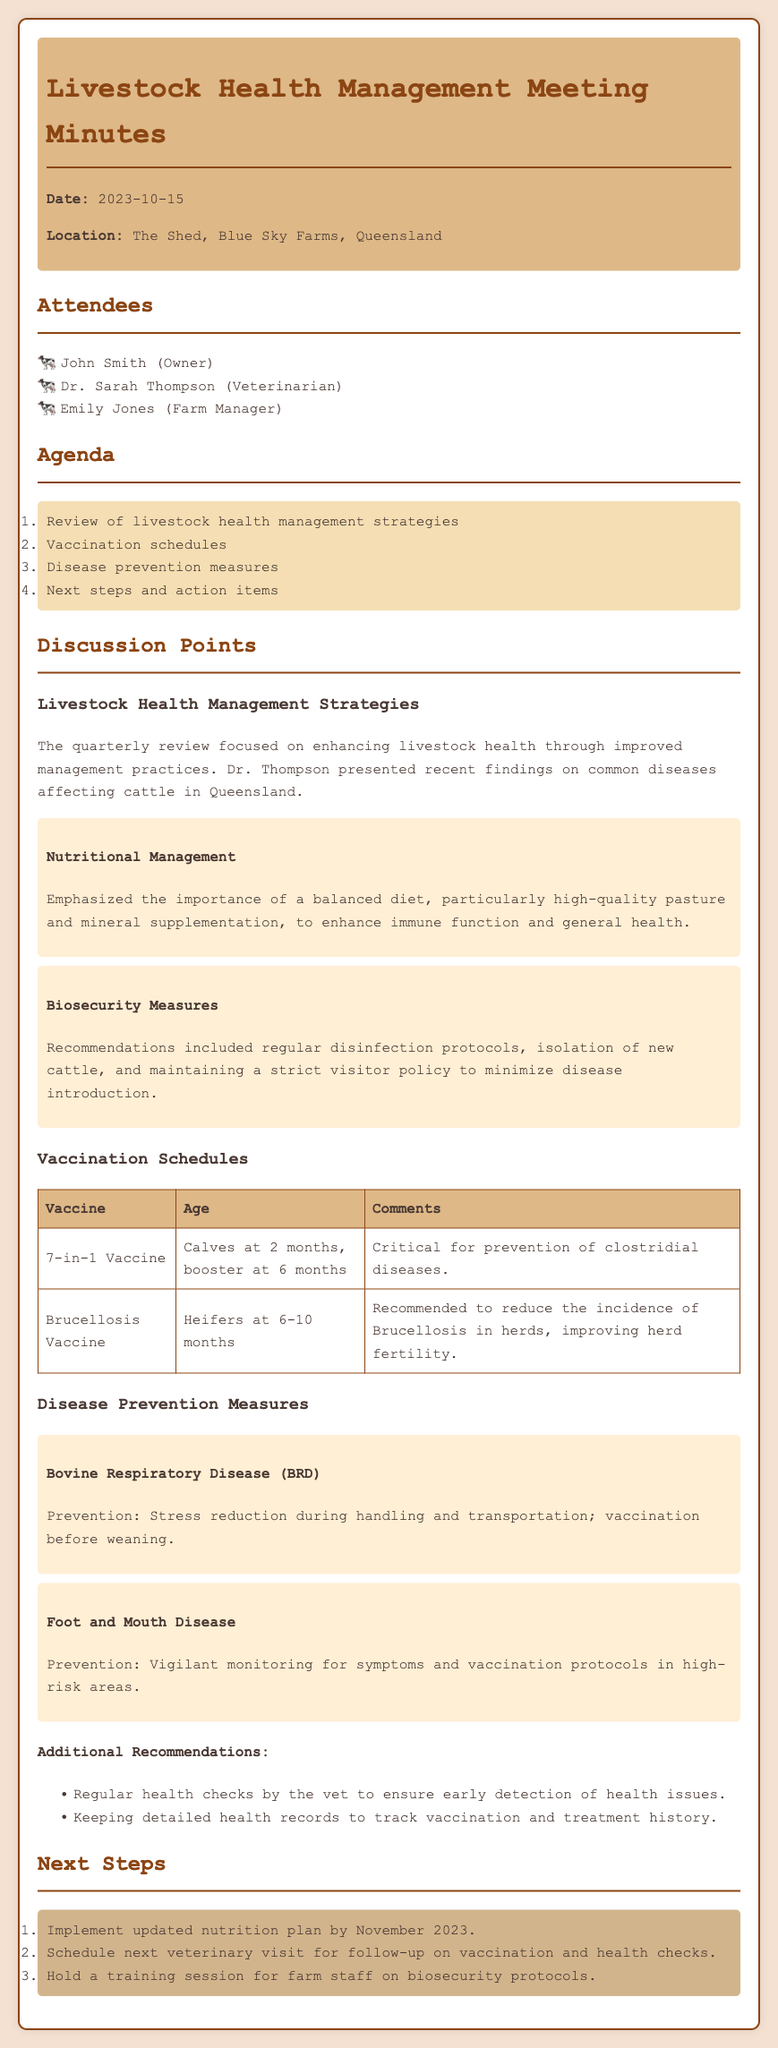What is the date of the meeting? The date of the meeting is mentioned at the start of the document.
Answer: 2023-10-15 Who is the veterinarian present at the meeting? The attendees' section lists the participants of the meeting, including the veterinarian.
Answer: Dr. Sarah Thompson What vaccine is recommended for calves? The vaccination schedules table includes details on vaccines including one critical for calves.
Answer: 7-in-1 Vaccine What disease is associated with stress reduction during handling? The disease prevention measures discuss methods to prevent certain diseases including this one.
Answer: Bovine Respiratory Disease (BRD) How often should health checks by the vet be conducted? The additional recommendations suggest a specific action regarding health checks.
Answer: Regularly What is the next step planned for the nutrition plan? The next steps outline plans, including times for implementing the nutrition plan.
Answer: By November 2023 What measures are included for biosecurity? The document lists specific recommendations regarding biosecurity in the strategy section.
Answer: Regular disinfection protocols What age should heifers receive the Brucellosis vaccine? The vaccination schedules table provides age details for the Brucellosis vaccine for heifers.
Answer: 6-10 months What is the main focus of the meeting? The agenda outlines the key topics discussed in the meeting regarding livestock health.
Answer: Livestock health management strategies 